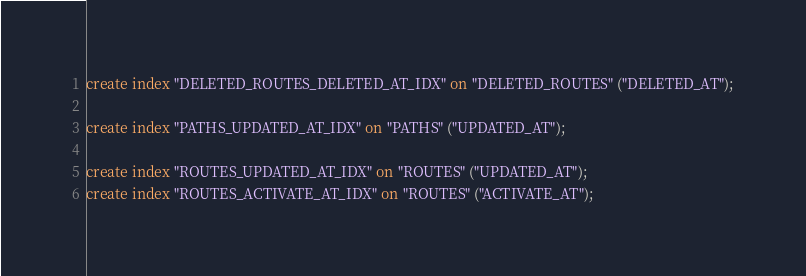Convert code to text. <code><loc_0><loc_0><loc_500><loc_500><_SQL_>create index "DELETED_ROUTES_DELETED_AT_IDX" on "DELETED_ROUTES" ("DELETED_AT");

create index "PATHS_UPDATED_AT_IDX" on "PATHS" ("UPDATED_AT");

create index "ROUTES_UPDATED_AT_IDX" on "ROUTES" ("UPDATED_AT");
create index "ROUTES_ACTIVATE_AT_IDX" on "ROUTES" ("ACTIVATE_AT");
</code> 